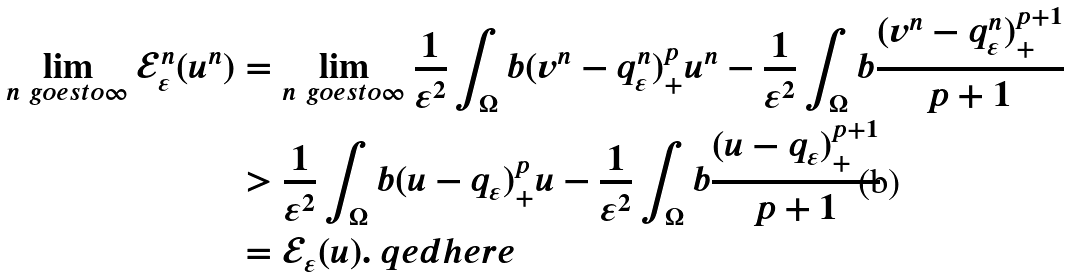Convert formula to latex. <formula><loc_0><loc_0><loc_500><loc_500>\lim _ { n \ g o e s t o \infty } \mathcal { E } _ { \varepsilon } ^ { n } ( u ^ { n } ) & = \lim _ { n \ g o e s t o \infty } \frac { 1 } { \varepsilon ^ { 2 } } \int _ { \Omega } b ( v ^ { n } - q _ { \varepsilon } ^ { n } ) _ { + } ^ { p } u ^ { n } - \frac { 1 } { \varepsilon ^ { 2 } } \int _ { \Omega } b \frac { ( v ^ { n } - q _ { \varepsilon } ^ { n } ) ^ { p + 1 } _ { + } } { p + 1 } \\ & > \frac { 1 } { \varepsilon ^ { 2 } } \int _ { \Omega } b ( u - q _ { \varepsilon } ) _ { + } ^ { p } u - \frac { 1 } { \varepsilon ^ { 2 } } \int _ { \Omega } b \frac { ( u - q _ { \varepsilon } ) ^ { p + 1 } _ { + } } { p + 1 } \\ & = \mathcal { E } _ { \varepsilon } ( u ) . \ q e d h e r e</formula> 